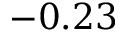<formula> <loc_0><loc_0><loc_500><loc_500>- 0 . 2 3</formula> 